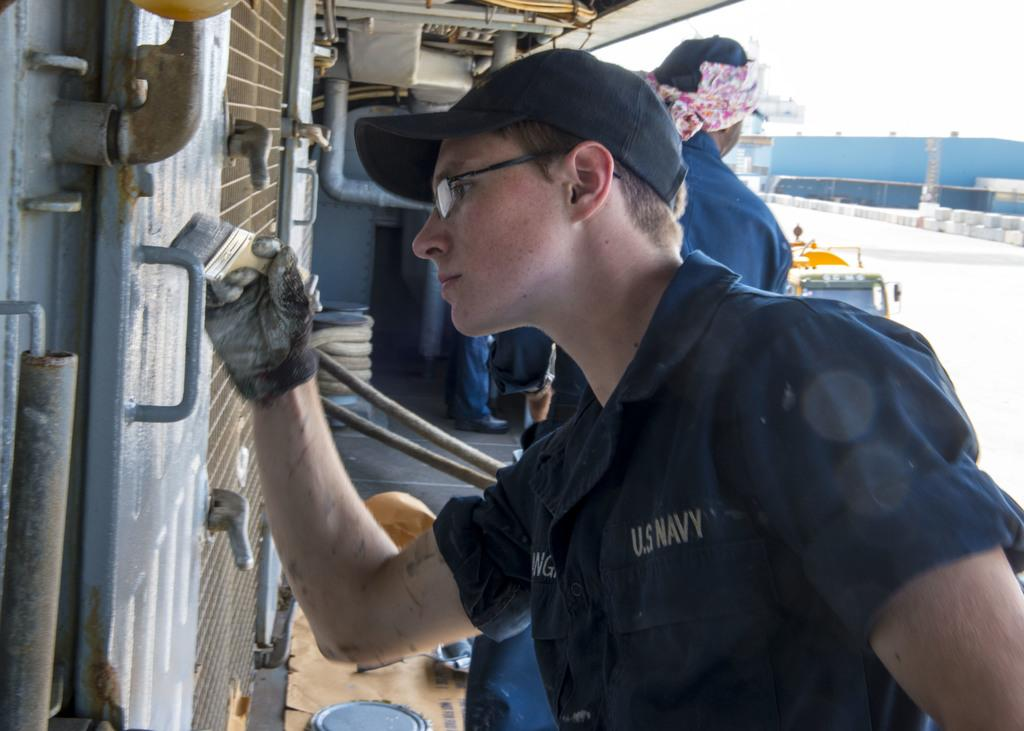What is the man in the image holding? The man is holding a paintbrush in the image. Can you describe the other person in the image? There is another man in the image. What can be seen in the background of the image? There is a building in the background of the image. What else is present in the image? There is a vehicle in the image. What part of the natural environment is visible in the image? The sky is visible in the image. Is the man using an umbrella to paint in the image? There is no umbrella present in the image, and the man is holding a paintbrush, not an umbrella. 